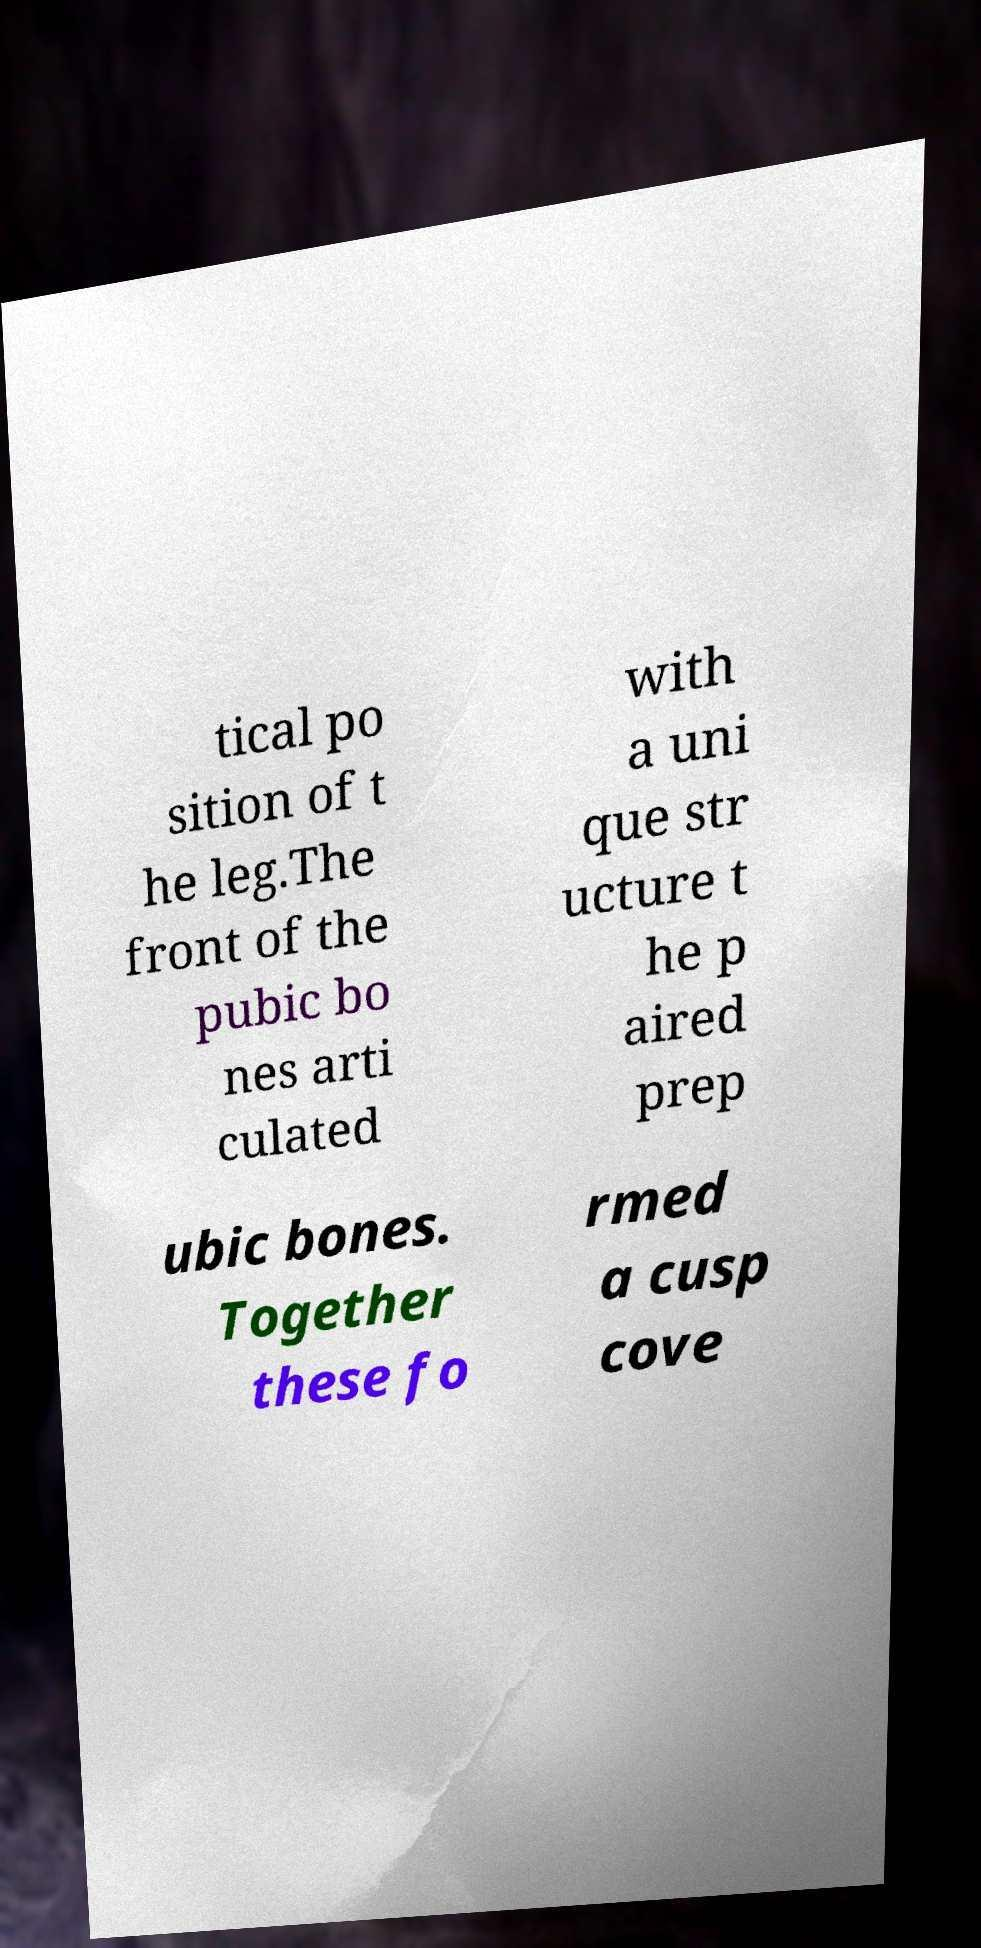I need the written content from this picture converted into text. Can you do that? tical po sition of t he leg.The front of the pubic bo nes arti culated with a uni que str ucture t he p aired prep ubic bones. Together these fo rmed a cusp cove 